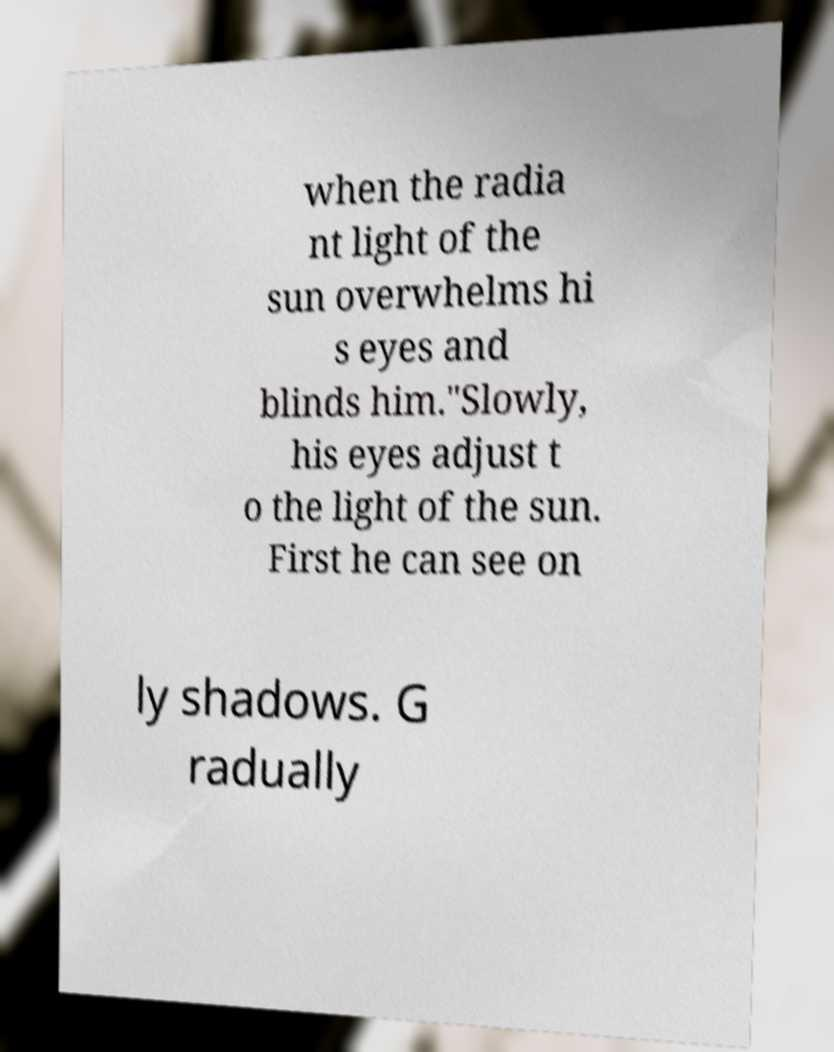Could you assist in decoding the text presented in this image and type it out clearly? when the radia nt light of the sun overwhelms hi s eyes and blinds him."Slowly, his eyes adjust t o the light of the sun. First he can see on ly shadows. G radually 